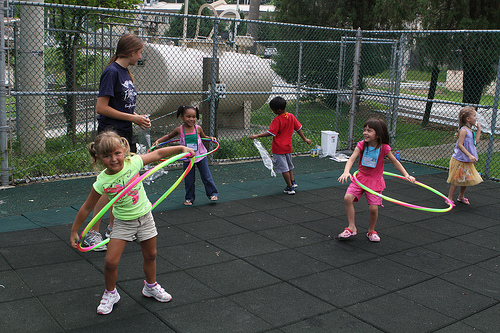<image>
Is the shorts next to the shirt? No. The shorts is not positioned next to the shirt. They are located in different areas of the scene. 